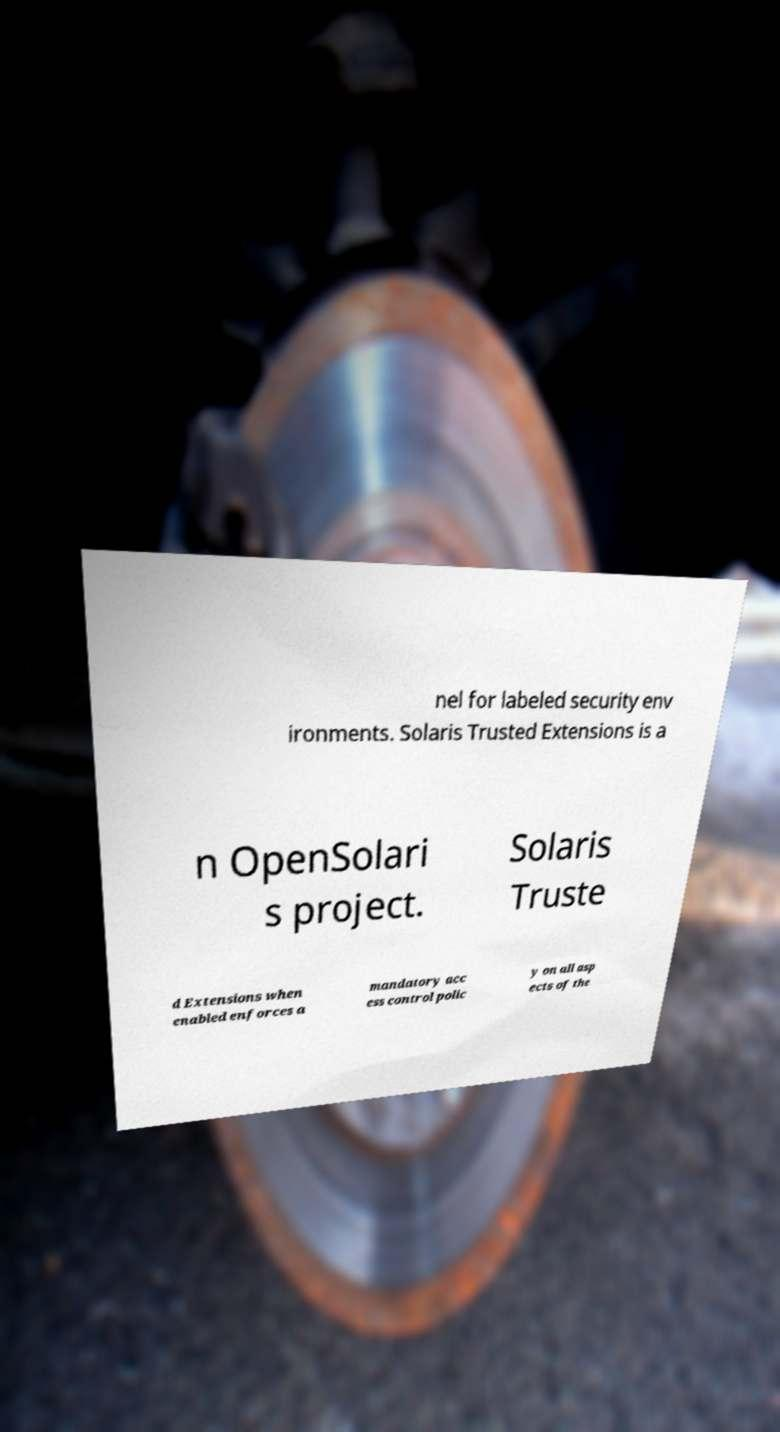Could you extract and type out the text from this image? nel for labeled security env ironments. Solaris Trusted Extensions is a n OpenSolari s project. Solaris Truste d Extensions when enabled enforces a mandatory acc ess control polic y on all asp ects of the 